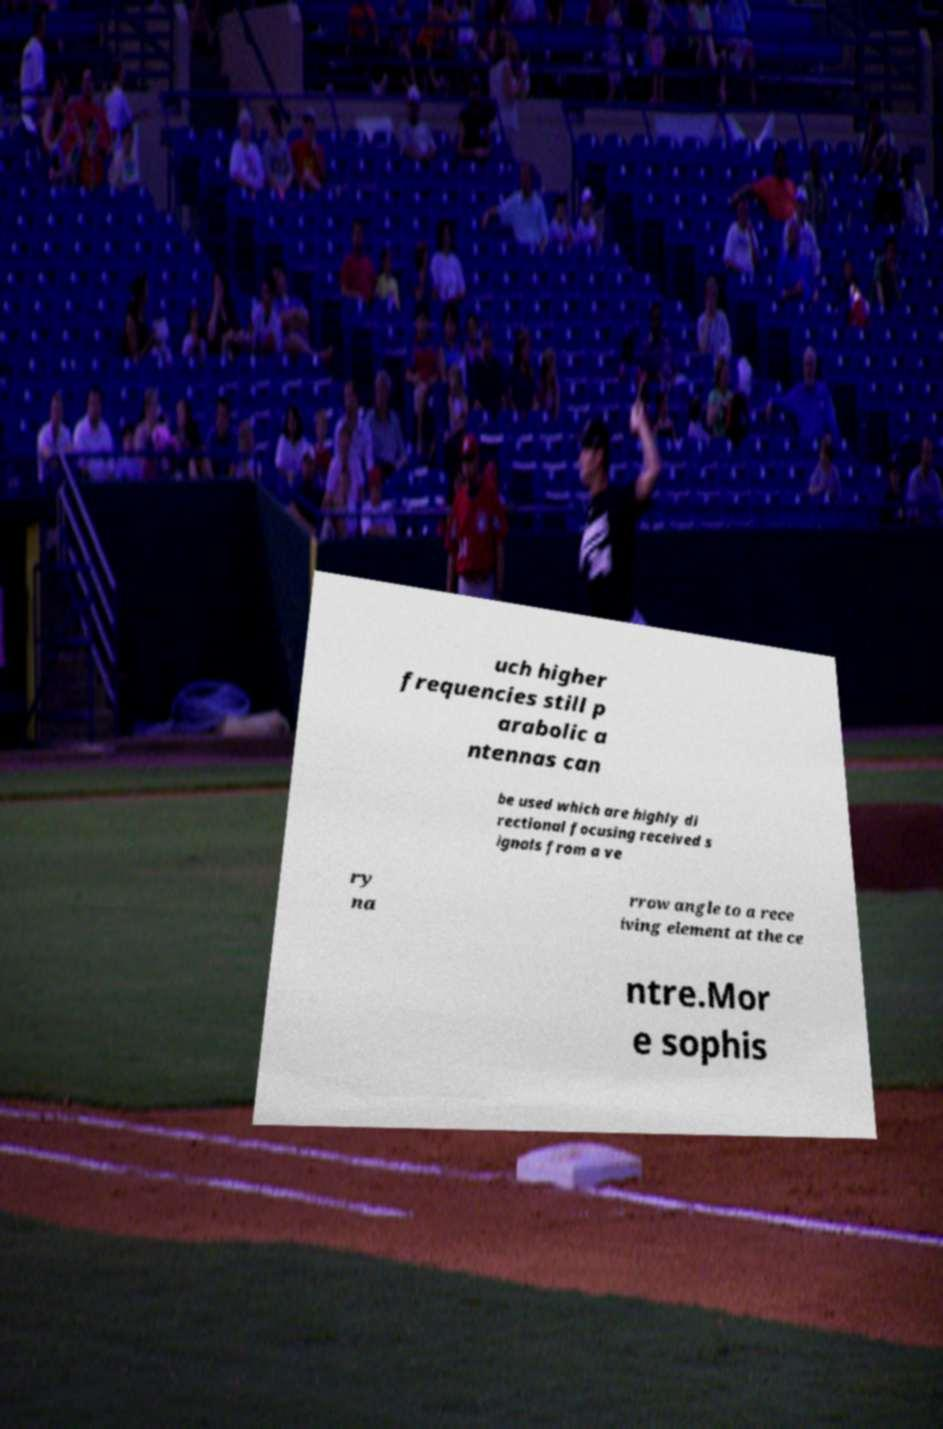Can you accurately transcribe the text from the provided image for me? uch higher frequencies still p arabolic a ntennas can be used which are highly di rectional focusing received s ignals from a ve ry na rrow angle to a rece iving element at the ce ntre.Mor e sophis 